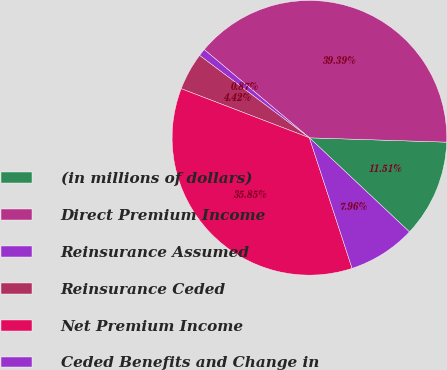Convert chart to OTSL. <chart><loc_0><loc_0><loc_500><loc_500><pie_chart><fcel>(in millions of dollars)<fcel>Direct Premium Income<fcel>Reinsurance Assumed<fcel>Reinsurance Ceded<fcel>Net Premium Income<fcel>Ceded Benefits and Change in<nl><fcel>11.51%<fcel>39.39%<fcel>0.87%<fcel>4.42%<fcel>35.85%<fcel>7.96%<nl></chart> 